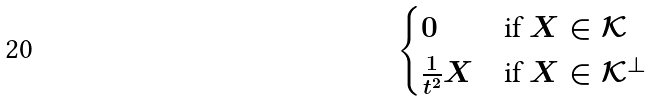<formula> <loc_0><loc_0><loc_500><loc_500>\begin{cases} 0 & \text {if } X \in \mathcal { K } \\ \frac { 1 } { t ^ { 2 } } X & \text {if } X \in \mathcal { K } ^ { \perp } \end{cases}</formula> 